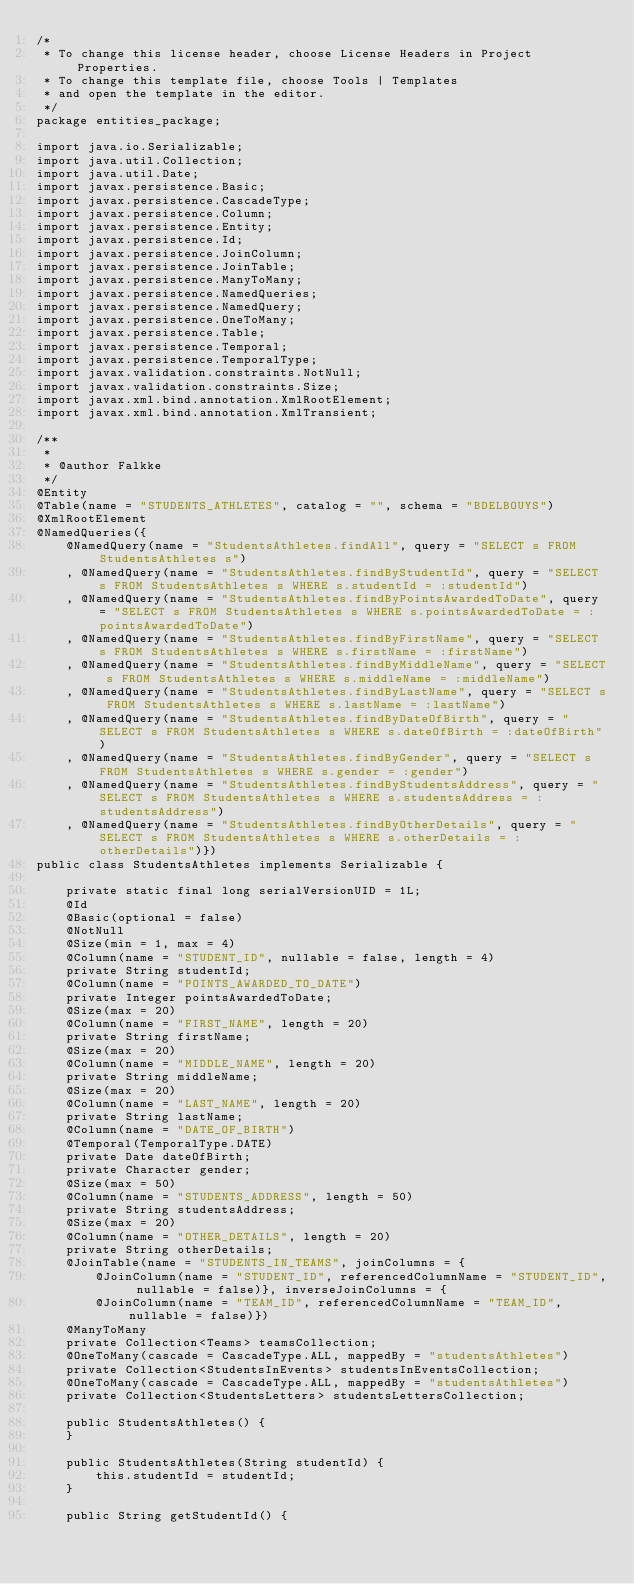<code> <loc_0><loc_0><loc_500><loc_500><_Java_>/*
 * To change this license header, choose License Headers in Project Properties.
 * To change this template file, choose Tools | Templates
 * and open the template in the editor.
 */
package entities_package;

import java.io.Serializable;
import java.util.Collection;
import java.util.Date;
import javax.persistence.Basic;
import javax.persistence.CascadeType;
import javax.persistence.Column;
import javax.persistence.Entity;
import javax.persistence.Id;
import javax.persistence.JoinColumn;
import javax.persistence.JoinTable;
import javax.persistence.ManyToMany;
import javax.persistence.NamedQueries;
import javax.persistence.NamedQuery;
import javax.persistence.OneToMany;
import javax.persistence.Table;
import javax.persistence.Temporal;
import javax.persistence.TemporalType;
import javax.validation.constraints.NotNull;
import javax.validation.constraints.Size;
import javax.xml.bind.annotation.XmlRootElement;
import javax.xml.bind.annotation.XmlTransient;

/**
 *
 * @author Falkke
 */
@Entity
@Table(name = "STUDENTS_ATHLETES", catalog = "", schema = "BDELBOUYS")
@XmlRootElement
@NamedQueries({
    @NamedQuery(name = "StudentsAthletes.findAll", query = "SELECT s FROM StudentsAthletes s")
    , @NamedQuery(name = "StudentsAthletes.findByStudentId", query = "SELECT s FROM StudentsAthletes s WHERE s.studentId = :studentId")
    , @NamedQuery(name = "StudentsAthletes.findByPointsAwardedToDate", query = "SELECT s FROM StudentsAthletes s WHERE s.pointsAwardedToDate = :pointsAwardedToDate")
    , @NamedQuery(name = "StudentsAthletes.findByFirstName", query = "SELECT s FROM StudentsAthletes s WHERE s.firstName = :firstName")
    , @NamedQuery(name = "StudentsAthletes.findByMiddleName", query = "SELECT s FROM StudentsAthletes s WHERE s.middleName = :middleName")
    , @NamedQuery(name = "StudentsAthletes.findByLastName", query = "SELECT s FROM StudentsAthletes s WHERE s.lastName = :lastName")
    , @NamedQuery(name = "StudentsAthletes.findByDateOfBirth", query = "SELECT s FROM StudentsAthletes s WHERE s.dateOfBirth = :dateOfBirth")
    , @NamedQuery(name = "StudentsAthletes.findByGender", query = "SELECT s FROM StudentsAthletes s WHERE s.gender = :gender")
    , @NamedQuery(name = "StudentsAthletes.findByStudentsAddress", query = "SELECT s FROM StudentsAthletes s WHERE s.studentsAddress = :studentsAddress")
    , @NamedQuery(name = "StudentsAthletes.findByOtherDetails", query = "SELECT s FROM StudentsAthletes s WHERE s.otherDetails = :otherDetails")})
public class StudentsAthletes implements Serializable {

    private static final long serialVersionUID = 1L;
    @Id
    @Basic(optional = false)
    @NotNull
    @Size(min = 1, max = 4)
    @Column(name = "STUDENT_ID", nullable = false, length = 4)
    private String studentId;
    @Column(name = "POINTS_AWARDED_TO_DATE")
    private Integer pointsAwardedToDate;
    @Size(max = 20)
    @Column(name = "FIRST_NAME", length = 20)
    private String firstName;
    @Size(max = 20)
    @Column(name = "MIDDLE_NAME", length = 20)
    private String middleName;
    @Size(max = 20)
    @Column(name = "LAST_NAME", length = 20)
    private String lastName;
    @Column(name = "DATE_OF_BIRTH")
    @Temporal(TemporalType.DATE)
    private Date dateOfBirth;
    private Character gender;
    @Size(max = 50)
    @Column(name = "STUDENTS_ADDRESS", length = 50)
    private String studentsAddress;
    @Size(max = 20)
    @Column(name = "OTHER_DETAILS", length = 20)
    private String otherDetails;
    @JoinTable(name = "STUDENTS_IN_TEAMS", joinColumns = {
        @JoinColumn(name = "STUDENT_ID", referencedColumnName = "STUDENT_ID", nullable = false)}, inverseJoinColumns = {
        @JoinColumn(name = "TEAM_ID", referencedColumnName = "TEAM_ID", nullable = false)})
    @ManyToMany
    private Collection<Teams> teamsCollection;
    @OneToMany(cascade = CascadeType.ALL, mappedBy = "studentsAthletes")
    private Collection<StudentsInEvents> studentsInEventsCollection;
    @OneToMany(cascade = CascadeType.ALL, mappedBy = "studentsAthletes")
    private Collection<StudentsLetters> studentsLettersCollection;

    public StudentsAthletes() {
    }

    public StudentsAthletes(String studentId) {
        this.studentId = studentId;
    }

    public String getStudentId() {</code> 